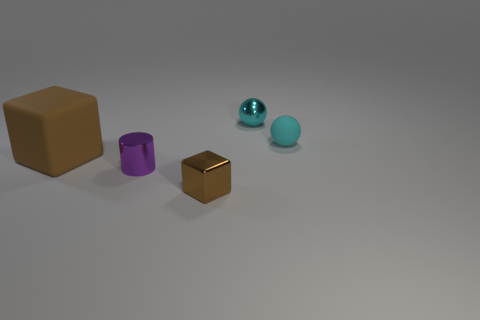Add 5 large brown cubes. How many objects exist? 10 Subtract all blocks. How many objects are left? 3 Subtract all gray cylinders. Subtract all purple cubes. How many cylinders are left? 1 Subtract all purple cylinders. How many purple cubes are left? 0 Subtract all small rubber cylinders. Subtract all big brown blocks. How many objects are left? 4 Add 1 small cyan metallic spheres. How many small cyan metallic spheres are left? 2 Add 3 brown cubes. How many brown cubes exist? 5 Subtract 0 gray cubes. How many objects are left? 5 Subtract 1 cylinders. How many cylinders are left? 0 